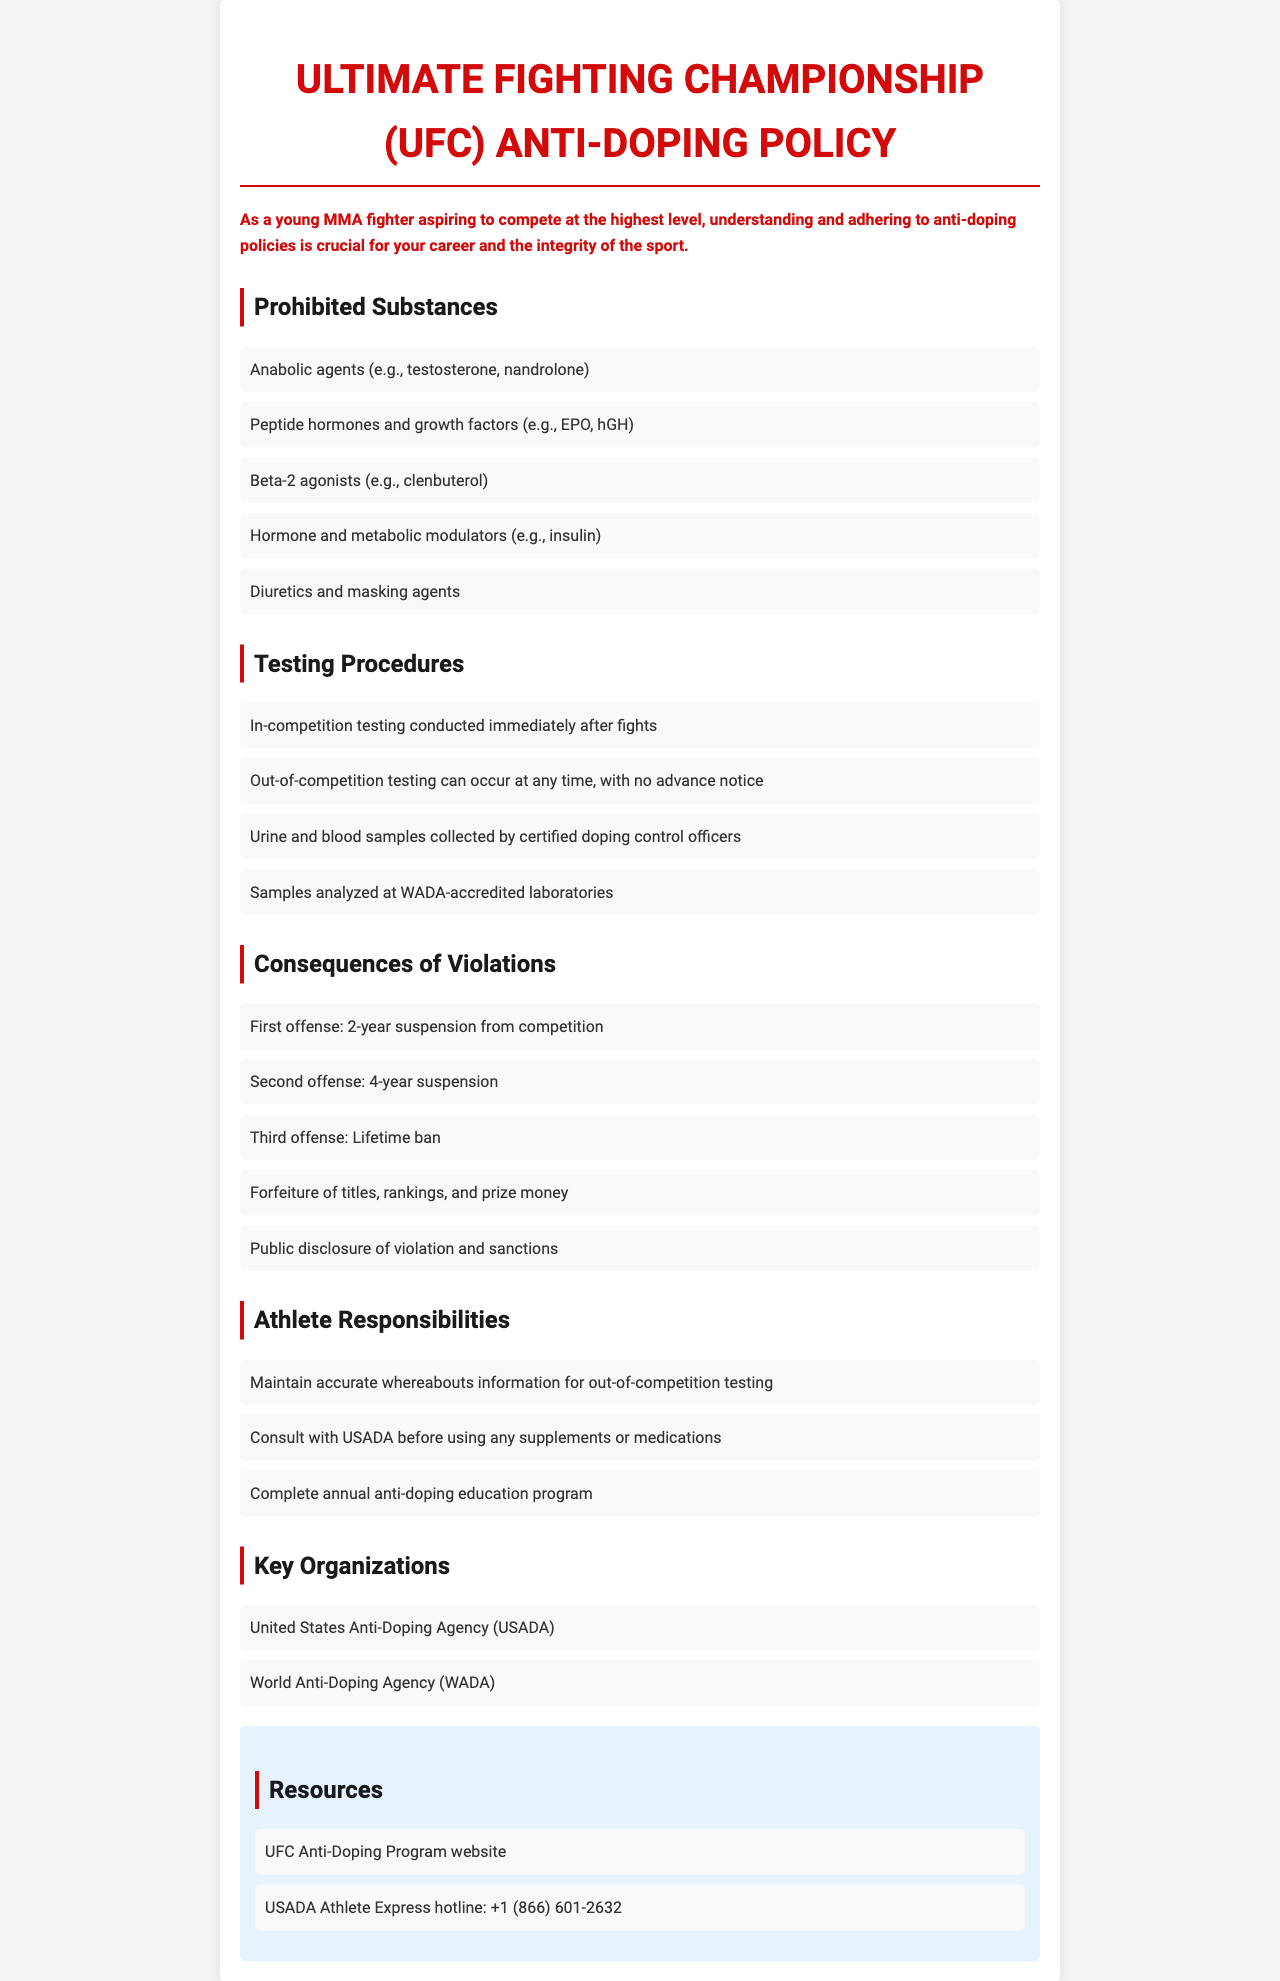What are anabolic agents? Anabolic agents are a category of prohibited substances that include examples like testosterone and nandrolone.
Answer: Anabolic agents What is the consequence for a second offense? The consequence for a second offense, as detailed in the document, is a 4-year suspension from competition.
Answer: 4-year suspension Which organization conducts in-competition testing? The organization responsible for conducting in-competition testing is the United States Anti-Doping Agency (USADA).
Answer: USADA What are the testing samples collected by? The samples collected for doping tests are collected by certified doping control officers.
Answer: Certified doping control officers What is the duration of the first suspension for violations? The document states that the duration of the first suspension for violations is 2 years.
Answer: 2 years What should an athlete do before using any supplements? An athlete should consult with USADA before using any supplements or medications.
Answer: Consult with USADA What is the title of this policy document? The title of the document specifically is "Ultimate Fighting Championship (UFC) Anti-Doping Policy".
Answer: Ultimate Fighting Championship (UFC) Anti-Doping Policy What is hGH categorized as? hGH is categorized as a peptide hormone and growth factor, which is a prohibited substance.
Answer: Peptide hormone and growth factor How many years is the suspension for a third offense? The suspension for a third offense, as indicated in the document, is a lifetime ban.
Answer: Lifetime ban 